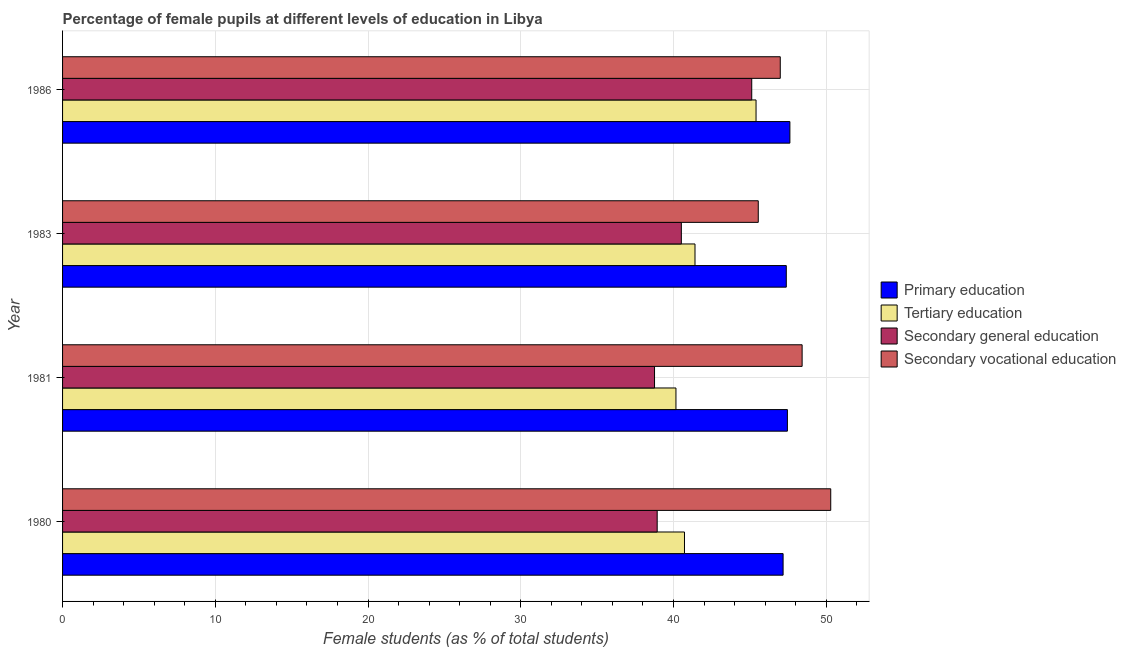How many groups of bars are there?
Provide a short and direct response. 4. Are the number of bars per tick equal to the number of legend labels?
Provide a succinct answer. Yes. Are the number of bars on each tick of the Y-axis equal?
Your answer should be compact. Yes. What is the percentage of female students in secondary vocational education in 1983?
Make the answer very short. 45.55. Across all years, what is the maximum percentage of female students in secondary vocational education?
Offer a very short reply. 50.29. Across all years, what is the minimum percentage of female students in primary education?
Keep it short and to the point. 47.18. In which year was the percentage of female students in secondary education maximum?
Provide a succinct answer. 1986. What is the total percentage of female students in primary education in the graph?
Your response must be concise. 189.64. What is the difference between the percentage of female students in secondary vocational education in 1980 and that in 1981?
Keep it short and to the point. 1.87. What is the difference between the percentage of female students in secondary education in 1980 and the percentage of female students in tertiary education in 1983?
Provide a short and direct response. -2.48. What is the average percentage of female students in secondary vocational education per year?
Provide a short and direct response. 47.81. In the year 1983, what is the difference between the percentage of female students in secondary education and percentage of female students in secondary vocational education?
Make the answer very short. -5.04. In how many years, is the percentage of female students in tertiary education greater than 12 %?
Provide a succinct answer. 4. What is the ratio of the percentage of female students in tertiary education in 1980 to that in 1983?
Offer a very short reply. 0.98. Is the percentage of female students in secondary education in 1981 less than that in 1983?
Your answer should be very brief. Yes. Is the difference between the percentage of female students in secondary education in 1983 and 1986 greater than the difference between the percentage of female students in primary education in 1983 and 1986?
Provide a succinct answer. No. What is the difference between the highest and the second highest percentage of female students in primary education?
Provide a succinct answer. 0.16. What is the difference between the highest and the lowest percentage of female students in secondary vocational education?
Offer a terse response. 4.75. In how many years, is the percentage of female students in primary education greater than the average percentage of female students in primary education taken over all years?
Your answer should be very brief. 2. Is the sum of the percentage of female students in secondary education in 1983 and 1986 greater than the maximum percentage of female students in primary education across all years?
Your response must be concise. Yes. Is it the case that in every year, the sum of the percentage of female students in secondary vocational education and percentage of female students in primary education is greater than the sum of percentage of female students in secondary education and percentage of female students in tertiary education?
Provide a short and direct response. No. What does the 2nd bar from the top in 1980 represents?
Make the answer very short. Secondary general education. What does the 1st bar from the bottom in 1981 represents?
Keep it short and to the point. Primary education. How many bars are there?
Give a very brief answer. 16. Does the graph contain any zero values?
Provide a short and direct response. No. How many legend labels are there?
Provide a short and direct response. 4. What is the title of the graph?
Give a very brief answer. Percentage of female pupils at different levels of education in Libya. Does "Revenue mobilization" appear as one of the legend labels in the graph?
Offer a very short reply. No. What is the label or title of the X-axis?
Your answer should be compact. Female students (as % of total students). What is the Female students (as % of total students) in Primary education in 1980?
Your response must be concise. 47.18. What is the Female students (as % of total students) of Tertiary education in 1980?
Provide a short and direct response. 40.72. What is the Female students (as % of total students) of Secondary general education in 1980?
Your answer should be very brief. 38.93. What is the Female students (as % of total students) of Secondary vocational education in 1980?
Your response must be concise. 50.29. What is the Female students (as % of total students) of Primary education in 1981?
Your response must be concise. 47.46. What is the Female students (as % of total students) in Tertiary education in 1981?
Provide a short and direct response. 40.16. What is the Female students (as % of total students) in Secondary general education in 1981?
Offer a very short reply. 38.76. What is the Female students (as % of total students) in Secondary vocational education in 1981?
Your answer should be compact. 48.42. What is the Female students (as % of total students) of Primary education in 1983?
Make the answer very short. 47.38. What is the Female students (as % of total students) of Tertiary education in 1983?
Make the answer very short. 41.41. What is the Female students (as % of total students) in Secondary general education in 1983?
Keep it short and to the point. 40.51. What is the Female students (as % of total students) in Secondary vocational education in 1983?
Offer a terse response. 45.55. What is the Female students (as % of total students) in Primary education in 1986?
Your response must be concise. 47.62. What is the Female students (as % of total students) in Tertiary education in 1986?
Make the answer very short. 45.4. What is the Female students (as % of total students) of Secondary general education in 1986?
Your answer should be compact. 45.12. What is the Female students (as % of total students) in Secondary vocational education in 1986?
Your answer should be very brief. 46.99. Across all years, what is the maximum Female students (as % of total students) in Primary education?
Keep it short and to the point. 47.62. Across all years, what is the maximum Female students (as % of total students) of Tertiary education?
Your response must be concise. 45.4. Across all years, what is the maximum Female students (as % of total students) in Secondary general education?
Your answer should be very brief. 45.12. Across all years, what is the maximum Female students (as % of total students) in Secondary vocational education?
Your answer should be compact. 50.29. Across all years, what is the minimum Female students (as % of total students) in Primary education?
Your response must be concise. 47.18. Across all years, what is the minimum Female students (as % of total students) in Tertiary education?
Your response must be concise. 40.16. Across all years, what is the minimum Female students (as % of total students) in Secondary general education?
Your response must be concise. 38.76. Across all years, what is the minimum Female students (as % of total students) of Secondary vocational education?
Your answer should be very brief. 45.55. What is the total Female students (as % of total students) of Primary education in the graph?
Make the answer very short. 189.64. What is the total Female students (as % of total students) of Tertiary education in the graph?
Offer a terse response. 167.69. What is the total Female students (as % of total students) in Secondary general education in the graph?
Offer a very short reply. 163.32. What is the total Female students (as % of total students) in Secondary vocational education in the graph?
Offer a terse response. 191.25. What is the difference between the Female students (as % of total students) in Primary education in 1980 and that in 1981?
Give a very brief answer. -0.28. What is the difference between the Female students (as % of total students) of Tertiary education in 1980 and that in 1981?
Give a very brief answer. 0.56. What is the difference between the Female students (as % of total students) in Secondary general education in 1980 and that in 1981?
Offer a very short reply. 0.17. What is the difference between the Female students (as % of total students) in Secondary vocational education in 1980 and that in 1981?
Keep it short and to the point. 1.87. What is the difference between the Female students (as % of total students) of Primary education in 1980 and that in 1983?
Provide a short and direct response. -0.21. What is the difference between the Female students (as % of total students) in Tertiary education in 1980 and that in 1983?
Your response must be concise. -0.69. What is the difference between the Female students (as % of total students) of Secondary general education in 1980 and that in 1983?
Offer a very short reply. -1.58. What is the difference between the Female students (as % of total students) of Secondary vocational education in 1980 and that in 1983?
Ensure brevity in your answer.  4.75. What is the difference between the Female students (as % of total students) in Primary education in 1980 and that in 1986?
Provide a succinct answer. -0.45. What is the difference between the Female students (as % of total students) of Tertiary education in 1980 and that in 1986?
Provide a succinct answer. -4.69. What is the difference between the Female students (as % of total students) of Secondary general education in 1980 and that in 1986?
Ensure brevity in your answer.  -6.19. What is the difference between the Female students (as % of total students) of Secondary vocational education in 1980 and that in 1986?
Offer a very short reply. 3.3. What is the difference between the Female students (as % of total students) of Primary education in 1981 and that in 1983?
Your answer should be very brief. 0.07. What is the difference between the Female students (as % of total students) in Tertiary education in 1981 and that in 1983?
Provide a short and direct response. -1.25. What is the difference between the Female students (as % of total students) of Secondary general education in 1981 and that in 1983?
Offer a very short reply. -1.76. What is the difference between the Female students (as % of total students) in Secondary vocational education in 1981 and that in 1983?
Your answer should be compact. 2.87. What is the difference between the Female students (as % of total students) in Primary education in 1981 and that in 1986?
Provide a short and direct response. -0.16. What is the difference between the Female students (as % of total students) in Tertiary education in 1981 and that in 1986?
Offer a very short reply. -5.24. What is the difference between the Female students (as % of total students) of Secondary general education in 1981 and that in 1986?
Make the answer very short. -6.37. What is the difference between the Female students (as % of total students) in Secondary vocational education in 1981 and that in 1986?
Keep it short and to the point. 1.43. What is the difference between the Female students (as % of total students) of Primary education in 1983 and that in 1986?
Ensure brevity in your answer.  -0.24. What is the difference between the Female students (as % of total students) in Tertiary education in 1983 and that in 1986?
Ensure brevity in your answer.  -4. What is the difference between the Female students (as % of total students) of Secondary general education in 1983 and that in 1986?
Give a very brief answer. -4.61. What is the difference between the Female students (as % of total students) in Secondary vocational education in 1983 and that in 1986?
Offer a terse response. -1.44. What is the difference between the Female students (as % of total students) of Primary education in 1980 and the Female students (as % of total students) of Tertiary education in 1981?
Offer a terse response. 7.02. What is the difference between the Female students (as % of total students) in Primary education in 1980 and the Female students (as % of total students) in Secondary general education in 1981?
Offer a terse response. 8.42. What is the difference between the Female students (as % of total students) in Primary education in 1980 and the Female students (as % of total students) in Secondary vocational education in 1981?
Provide a succinct answer. -1.25. What is the difference between the Female students (as % of total students) in Tertiary education in 1980 and the Female students (as % of total students) in Secondary general education in 1981?
Your answer should be very brief. 1.96. What is the difference between the Female students (as % of total students) of Tertiary education in 1980 and the Female students (as % of total students) of Secondary vocational education in 1981?
Offer a very short reply. -7.7. What is the difference between the Female students (as % of total students) of Secondary general education in 1980 and the Female students (as % of total students) of Secondary vocational education in 1981?
Offer a very short reply. -9.49. What is the difference between the Female students (as % of total students) of Primary education in 1980 and the Female students (as % of total students) of Tertiary education in 1983?
Offer a terse response. 5.77. What is the difference between the Female students (as % of total students) of Primary education in 1980 and the Female students (as % of total students) of Secondary general education in 1983?
Provide a succinct answer. 6.66. What is the difference between the Female students (as % of total students) of Primary education in 1980 and the Female students (as % of total students) of Secondary vocational education in 1983?
Your response must be concise. 1.63. What is the difference between the Female students (as % of total students) in Tertiary education in 1980 and the Female students (as % of total students) in Secondary general education in 1983?
Your answer should be compact. 0.21. What is the difference between the Female students (as % of total students) in Tertiary education in 1980 and the Female students (as % of total students) in Secondary vocational education in 1983?
Your answer should be very brief. -4.83. What is the difference between the Female students (as % of total students) of Secondary general education in 1980 and the Female students (as % of total students) of Secondary vocational education in 1983?
Ensure brevity in your answer.  -6.62. What is the difference between the Female students (as % of total students) of Primary education in 1980 and the Female students (as % of total students) of Tertiary education in 1986?
Offer a very short reply. 1.77. What is the difference between the Female students (as % of total students) in Primary education in 1980 and the Female students (as % of total students) in Secondary general education in 1986?
Your response must be concise. 2.05. What is the difference between the Female students (as % of total students) of Primary education in 1980 and the Female students (as % of total students) of Secondary vocational education in 1986?
Provide a succinct answer. 0.19. What is the difference between the Female students (as % of total students) of Tertiary education in 1980 and the Female students (as % of total students) of Secondary general education in 1986?
Provide a succinct answer. -4.4. What is the difference between the Female students (as % of total students) in Tertiary education in 1980 and the Female students (as % of total students) in Secondary vocational education in 1986?
Your answer should be very brief. -6.27. What is the difference between the Female students (as % of total students) of Secondary general education in 1980 and the Female students (as % of total students) of Secondary vocational education in 1986?
Your answer should be very brief. -8.06. What is the difference between the Female students (as % of total students) in Primary education in 1981 and the Female students (as % of total students) in Tertiary education in 1983?
Your response must be concise. 6.05. What is the difference between the Female students (as % of total students) in Primary education in 1981 and the Female students (as % of total students) in Secondary general education in 1983?
Your answer should be compact. 6.94. What is the difference between the Female students (as % of total students) of Primary education in 1981 and the Female students (as % of total students) of Secondary vocational education in 1983?
Give a very brief answer. 1.91. What is the difference between the Female students (as % of total students) of Tertiary education in 1981 and the Female students (as % of total students) of Secondary general education in 1983?
Offer a terse response. -0.35. What is the difference between the Female students (as % of total students) in Tertiary education in 1981 and the Female students (as % of total students) in Secondary vocational education in 1983?
Your answer should be compact. -5.39. What is the difference between the Female students (as % of total students) in Secondary general education in 1981 and the Female students (as % of total students) in Secondary vocational education in 1983?
Provide a succinct answer. -6.79. What is the difference between the Female students (as % of total students) of Primary education in 1981 and the Female students (as % of total students) of Tertiary education in 1986?
Offer a terse response. 2.05. What is the difference between the Female students (as % of total students) in Primary education in 1981 and the Female students (as % of total students) in Secondary general education in 1986?
Keep it short and to the point. 2.34. What is the difference between the Female students (as % of total students) of Primary education in 1981 and the Female students (as % of total students) of Secondary vocational education in 1986?
Your answer should be very brief. 0.47. What is the difference between the Female students (as % of total students) in Tertiary education in 1981 and the Female students (as % of total students) in Secondary general education in 1986?
Provide a short and direct response. -4.96. What is the difference between the Female students (as % of total students) in Tertiary education in 1981 and the Female students (as % of total students) in Secondary vocational education in 1986?
Your answer should be compact. -6.83. What is the difference between the Female students (as % of total students) in Secondary general education in 1981 and the Female students (as % of total students) in Secondary vocational education in 1986?
Offer a terse response. -8.23. What is the difference between the Female students (as % of total students) in Primary education in 1983 and the Female students (as % of total students) in Tertiary education in 1986?
Offer a terse response. 1.98. What is the difference between the Female students (as % of total students) of Primary education in 1983 and the Female students (as % of total students) of Secondary general education in 1986?
Offer a terse response. 2.26. What is the difference between the Female students (as % of total students) of Primary education in 1983 and the Female students (as % of total students) of Secondary vocational education in 1986?
Make the answer very short. 0.39. What is the difference between the Female students (as % of total students) of Tertiary education in 1983 and the Female students (as % of total students) of Secondary general education in 1986?
Offer a terse response. -3.71. What is the difference between the Female students (as % of total students) in Tertiary education in 1983 and the Female students (as % of total students) in Secondary vocational education in 1986?
Offer a very short reply. -5.58. What is the difference between the Female students (as % of total students) of Secondary general education in 1983 and the Female students (as % of total students) of Secondary vocational education in 1986?
Your answer should be compact. -6.48. What is the average Female students (as % of total students) of Primary education per year?
Your answer should be very brief. 47.41. What is the average Female students (as % of total students) in Tertiary education per year?
Your response must be concise. 41.92. What is the average Female students (as % of total students) in Secondary general education per year?
Give a very brief answer. 40.83. What is the average Female students (as % of total students) of Secondary vocational education per year?
Ensure brevity in your answer.  47.81. In the year 1980, what is the difference between the Female students (as % of total students) in Primary education and Female students (as % of total students) in Tertiary education?
Offer a terse response. 6.46. In the year 1980, what is the difference between the Female students (as % of total students) in Primary education and Female students (as % of total students) in Secondary general education?
Offer a terse response. 8.24. In the year 1980, what is the difference between the Female students (as % of total students) in Primary education and Female students (as % of total students) in Secondary vocational education?
Give a very brief answer. -3.12. In the year 1980, what is the difference between the Female students (as % of total students) in Tertiary education and Female students (as % of total students) in Secondary general education?
Your response must be concise. 1.79. In the year 1980, what is the difference between the Female students (as % of total students) of Tertiary education and Female students (as % of total students) of Secondary vocational education?
Your response must be concise. -9.58. In the year 1980, what is the difference between the Female students (as % of total students) in Secondary general education and Female students (as % of total students) in Secondary vocational education?
Your response must be concise. -11.36. In the year 1981, what is the difference between the Female students (as % of total students) in Primary education and Female students (as % of total students) in Tertiary education?
Give a very brief answer. 7.3. In the year 1981, what is the difference between the Female students (as % of total students) of Primary education and Female students (as % of total students) of Secondary general education?
Your answer should be compact. 8.7. In the year 1981, what is the difference between the Female students (as % of total students) of Primary education and Female students (as % of total students) of Secondary vocational education?
Keep it short and to the point. -0.96. In the year 1981, what is the difference between the Female students (as % of total students) of Tertiary education and Female students (as % of total students) of Secondary general education?
Make the answer very short. 1.4. In the year 1981, what is the difference between the Female students (as % of total students) in Tertiary education and Female students (as % of total students) in Secondary vocational education?
Offer a very short reply. -8.26. In the year 1981, what is the difference between the Female students (as % of total students) of Secondary general education and Female students (as % of total students) of Secondary vocational education?
Provide a succinct answer. -9.66. In the year 1983, what is the difference between the Female students (as % of total students) in Primary education and Female students (as % of total students) in Tertiary education?
Give a very brief answer. 5.98. In the year 1983, what is the difference between the Female students (as % of total students) of Primary education and Female students (as % of total students) of Secondary general education?
Give a very brief answer. 6.87. In the year 1983, what is the difference between the Female students (as % of total students) in Primary education and Female students (as % of total students) in Secondary vocational education?
Provide a succinct answer. 1.84. In the year 1983, what is the difference between the Female students (as % of total students) of Tertiary education and Female students (as % of total students) of Secondary general education?
Your answer should be very brief. 0.89. In the year 1983, what is the difference between the Female students (as % of total students) of Tertiary education and Female students (as % of total students) of Secondary vocational education?
Offer a very short reply. -4.14. In the year 1983, what is the difference between the Female students (as % of total students) of Secondary general education and Female students (as % of total students) of Secondary vocational education?
Make the answer very short. -5.04. In the year 1986, what is the difference between the Female students (as % of total students) of Primary education and Female students (as % of total students) of Tertiary education?
Give a very brief answer. 2.22. In the year 1986, what is the difference between the Female students (as % of total students) of Primary education and Female students (as % of total students) of Secondary general education?
Provide a short and direct response. 2.5. In the year 1986, what is the difference between the Female students (as % of total students) of Primary education and Female students (as % of total students) of Secondary vocational education?
Give a very brief answer. 0.63. In the year 1986, what is the difference between the Female students (as % of total students) in Tertiary education and Female students (as % of total students) in Secondary general education?
Give a very brief answer. 0.28. In the year 1986, what is the difference between the Female students (as % of total students) of Tertiary education and Female students (as % of total students) of Secondary vocational education?
Give a very brief answer. -1.59. In the year 1986, what is the difference between the Female students (as % of total students) in Secondary general education and Female students (as % of total students) in Secondary vocational education?
Offer a terse response. -1.87. What is the ratio of the Female students (as % of total students) in Tertiary education in 1980 to that in 1981?
Offer a very short reply. 1.01. What is the ratio of the Female students (as % of total students) of Secondary vocational education in 1980 to that in 1981?
Provide a short and direct response. 1.04. What is the ratio of the Female students (as % of total students) of Tertiary education in 1980 to that in 1983?
Offer a terse response. 0.98. What is the ratio of the Female students (as % of total students) in Secondary vocational education in 1980 to that in 1983?
Keep it short and to the point. 1.1. What is the ratio of the Female students (as % of total students) in Tertiary education in 1980 to that in 1986?
Ensure brevity in your answer.  0.9. What is the ratio of the Female students (as % of total students) of Secondary general education in 1980 to that in 1986?
Your response must be concise. 0.86. What is the ratio of the Female students (as % of total students) in Secondary vocational education in 1980 to that in 1986?
Offer a terse response. 1.07. What is the ratio of the Female students (as % of total students) in Primary education in 1981 to that in 1983?
Provide a succinct answer. 1. What is the ratio of the Female students (as % of total students) in Tertiary education in 1981 to that in 1983?
Ensure brevity in your answer.  0.97. What is the ratio of the Female students (as % of total students) of Secondary general education in 1981 to that in 1983?
Offer a terse response. 0.96. What is the ratio of the Female students (as % of total students) of Secondary vocational education in 1981 to that in 1983?
Ensure brevity in your answer.  1.06. What is the ratio of the Female students (as % of total students) in Tertiary education in 1981 to that in 1986?
Offer a very short reply. 0.88. What is the ratio of the Female students (as % of total students) in Secondary general education in 1981 to that in 1986?
Make the answer very short. 0.86. What is the ratio of the Female students (as % of total students) of Secondary vocational education in 1981 to that in 1986?
Provide a short and direct response. 1.03. What is the ratio of the Female students (as % of total students) in Tertiary education in 1983 to that in 1986?
Ensure brevity in your answer.  0.91. What is the ratio of the Female students (as % of total students) of Secondary general education in 1983 to that in 1986?
Offer a terse response. 0.9. What is the ratio of the Female students (as % of total students) of Secondary vocational education in 1983 to that in 1986?
Your response must be concise. 0.97. What is the difference between the highest and the second highest Female students (as % of total students) in Primary education?
Keep it short and to the point. 0.16. What is the difference between the highest and the second highest Female students (as % of total students) of Tertiary education?
Provide a succinct answer. 4. What is the difference between the highest and the second highest Female students (as % of total students) of Secondary general education?
Give a very brief answer. 4.61. What is the difference between the highest and the second highest Female students (as % of total students) of Secondary vocational education?
Give a very brief answer. 1.87. What is the difference between the highest and the lowest Female students (as % of total students) of Primary education?
Your answer should be compact. 0.45. What is the difference between the highest and the lowest Female students (as % of total students) of Tertiary education?
Provide a succinct answer. 5.24. What is the difference between the highest and the lowest Female students (as % of total students) of Secondary general education?
Offer a very short reply. 6.37. What is the difference between the highest and the lowest Female students (as % of total students) in Secondary vocational education?
Your answer should be very brief. 4.75. 